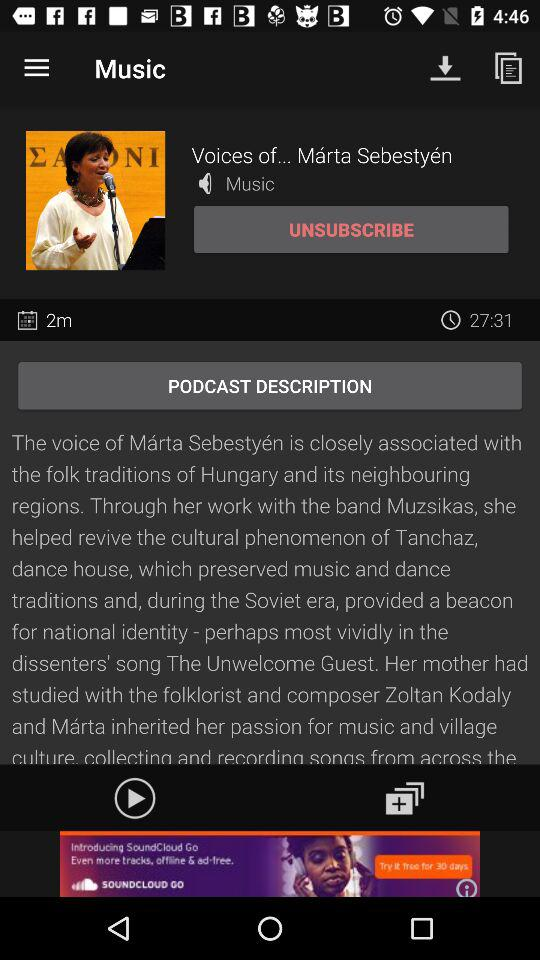How many people have downloaded this song?
When the provided information is insufficient, respond with <no answer>. <no answer> 